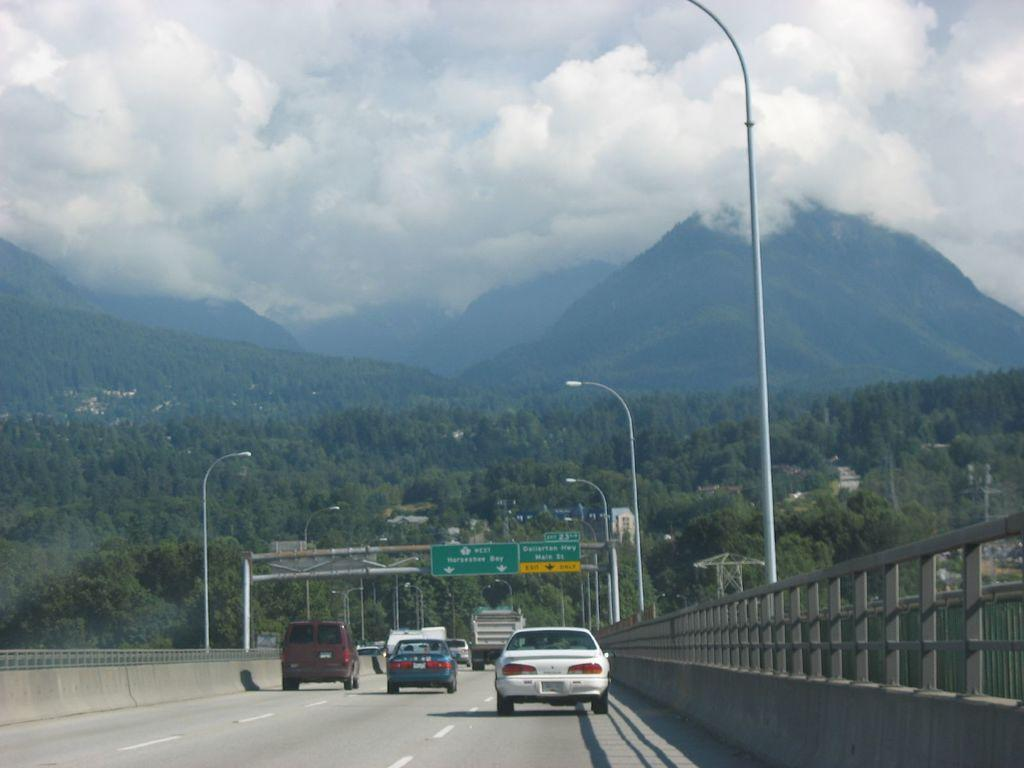What is the main feature of the image? There is a road in the image. What is happening on the road? Vehicles are present on the road. Are there any signs or markers along the road? Yes, there are sign boards in the image. What else can be seen in the image besides the road and vehicles? Poles are visible in the image. What can be seen in the background of the image? There are trees, hills, and the sky visible in the background of the image. How many geese are standing on the iron feet in the image? There are no geese or iron feet present in the image. What type of shoes are the people wearing on their feet in the image? There are no people visible in the image, so it is impossible to determine what type of shoes they might be wearing. 